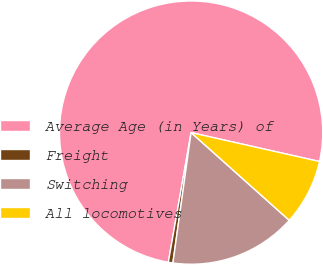<chart> <loc_0><loc_0><loc_500><loc_500><pie_chart><fcel>Average Age (in Years) of<fcel>Freight<fcel>Switching<fcel>All locomotives<nl><fcel>75.75%<fcel>0.56%<fcel>15.6%<fcel>8.08%<nl></chart> 